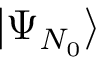<formula> <loc_0><loc_0><loc_500><loc_500>| \Psi _ { N _ { 0 } } \rangle</formula> 